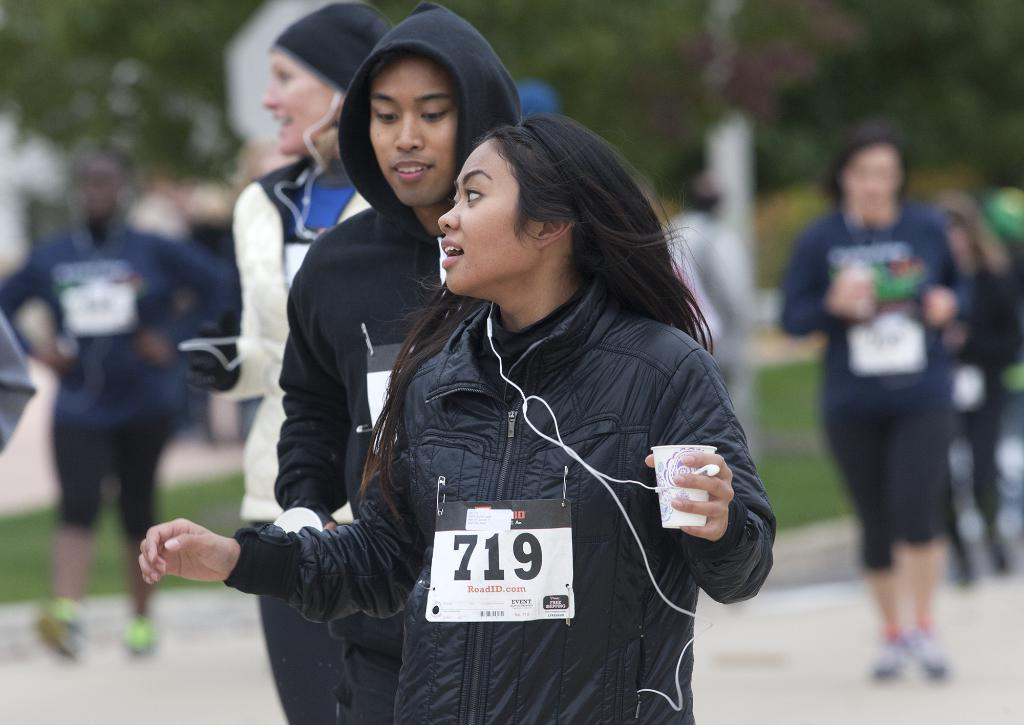How many people are in the image? There is a group of people in the image. Can you describe what one of the people is holding? There is a person holding a paper cup. What can be said about the background of the image? The background of the image is blurry. How many trees are visible in the image? There are no trees visible in the image. Does the existence of the group of people in the image prove the existence of cows? No, the existence of the group of people in the image does not prove the existence of cows, as there is no mention of cows in the provided facts. 